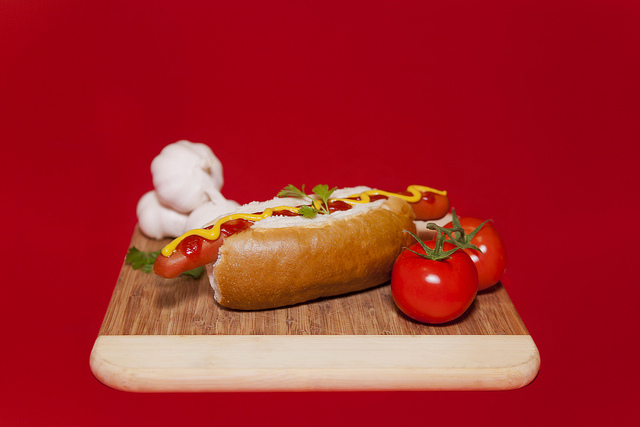What is on the hotdog? The hot dog is topped with mustard and ketchup, complemented with some parsley leaves for garnish. 